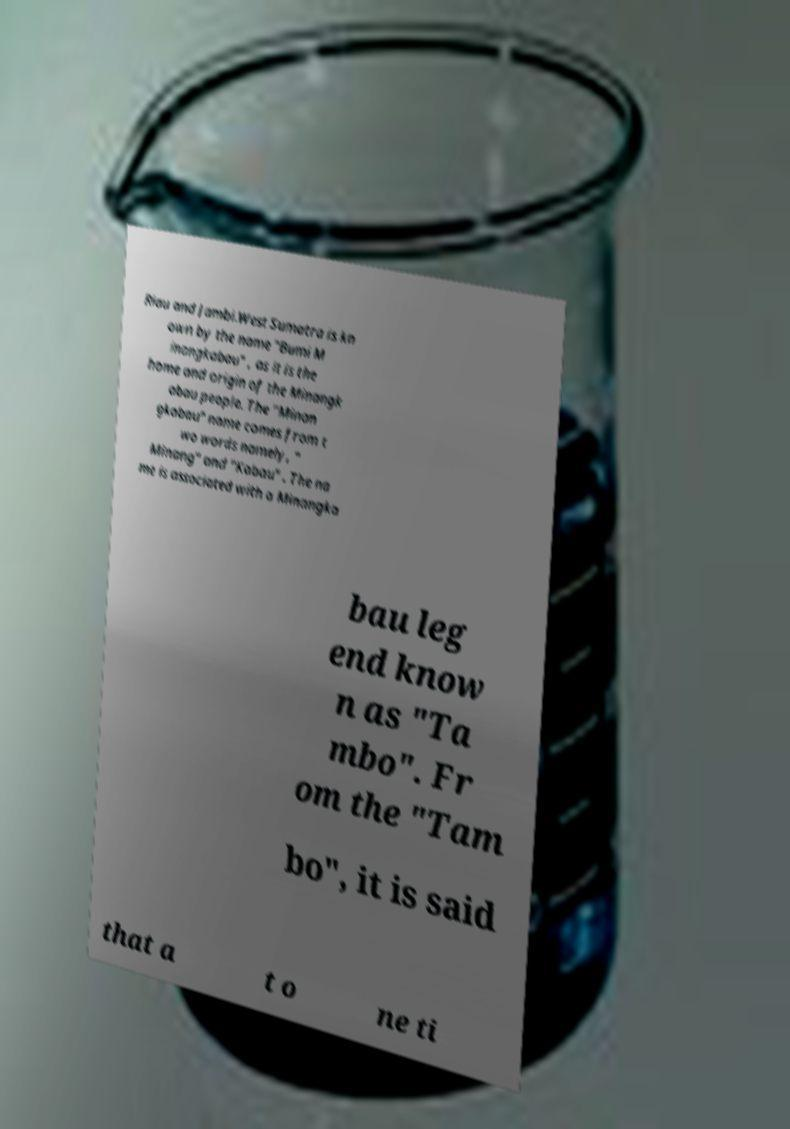Can you read and provide the text displayed in the image?This photo seems to have some interesting text. Can you extract and type it out for me? Riau and Jambi.West Sumatra is kn own by the name "Bumi M inangkabau" , as it is the home and origin of the Minangk abau people. The "Minan gkabau" name comes from t wo words namely, " Minang" and "Kabau" . The na me is associated with a Minangka bau leg end know n as "Ta mbo". Fr om the "Tam bo", it is said that a t o ne ti 